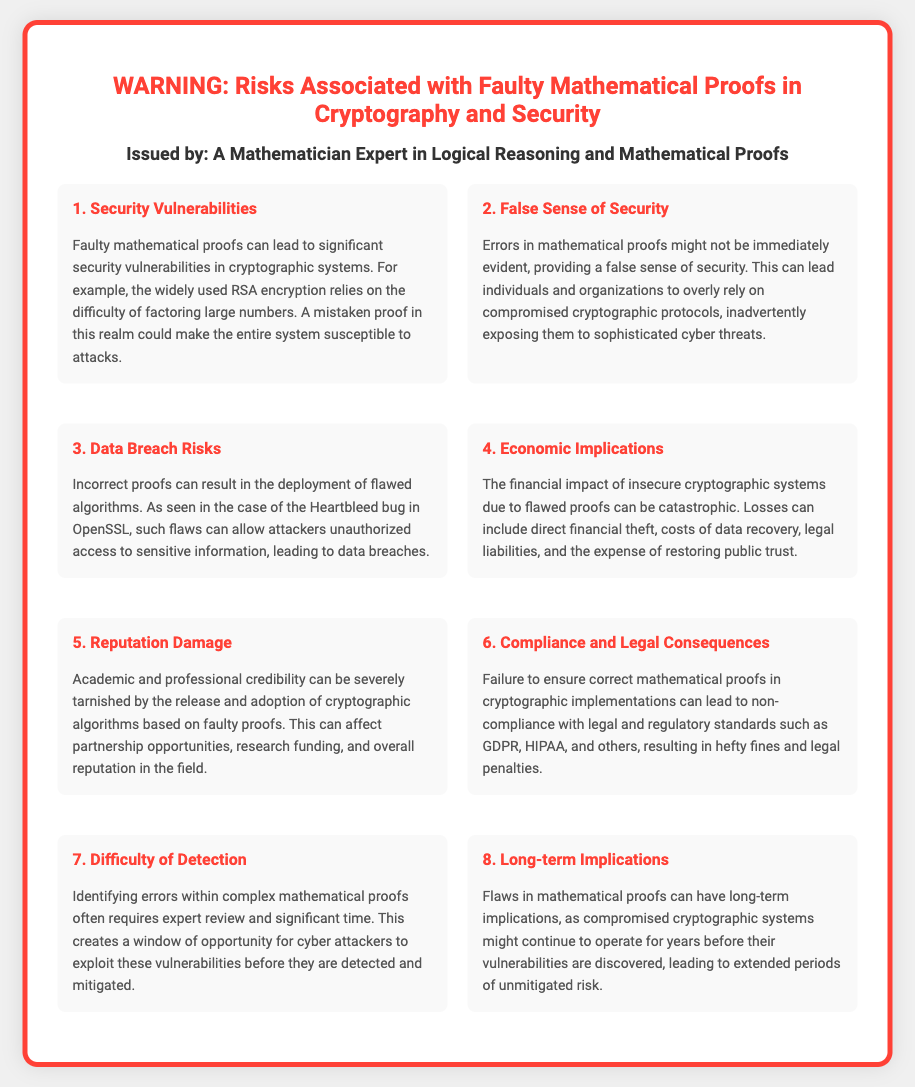What is the main topic of the warning label? The main topic revolves around the risks that arise from faulty mathematical proofs specifically in the context of cryptography and security.
Answer: Risks Associated with Faulty Mathematical Proofs in Cryptography and Security Who issued the warning? The warning label specifies that it is issued by an individual with expertise in the relevant field, indicating their authority on the subject matter.
Answer: A Mathematician Expert in Logical Reasoning and Mathematical Proofs What can faulty mathematical proofs lead to? The document lists various critical issues that can arise due to faulty mathematical proofs, highlighting the significant risks involved.
Answer: Security Vulnerabilities What notable example is given in relation to data breach risks? The document references a well-known incident that exemplifies the consequences of incorrect proofs and the resulting breaches it caused.
Answer: Heartbleed bug in OpenSSL What are the possible economic implications mentioned? The text refers to the financial consequences that can arise from using flawed cryptographic systems due to incorrect proofs, showing the broad impact on businesses and finance.
Answer: Catastrophic How many risks associated with faulty proofs are listed in the document? The warning label enumerates various risks, providing a clear overview of the potential issues that can arise from faulty mathematical proofs.
Answer: Eight What is suggested as a challenge in detecting errors in mathematical proofs? The document highlights a specific challenge associated with identifying errors, indicating a need for specific expertise and resources, which can lengthen the time needed for detection.
Answer: Difficulty of Detection What consequence is mentioned regarding legal compliance? The document indicates that non-compliance due to flawed proofs can have serious repercussions, emphasizing the importance of adhering to regulations.
Answer: Hefty fines and legal penalties 